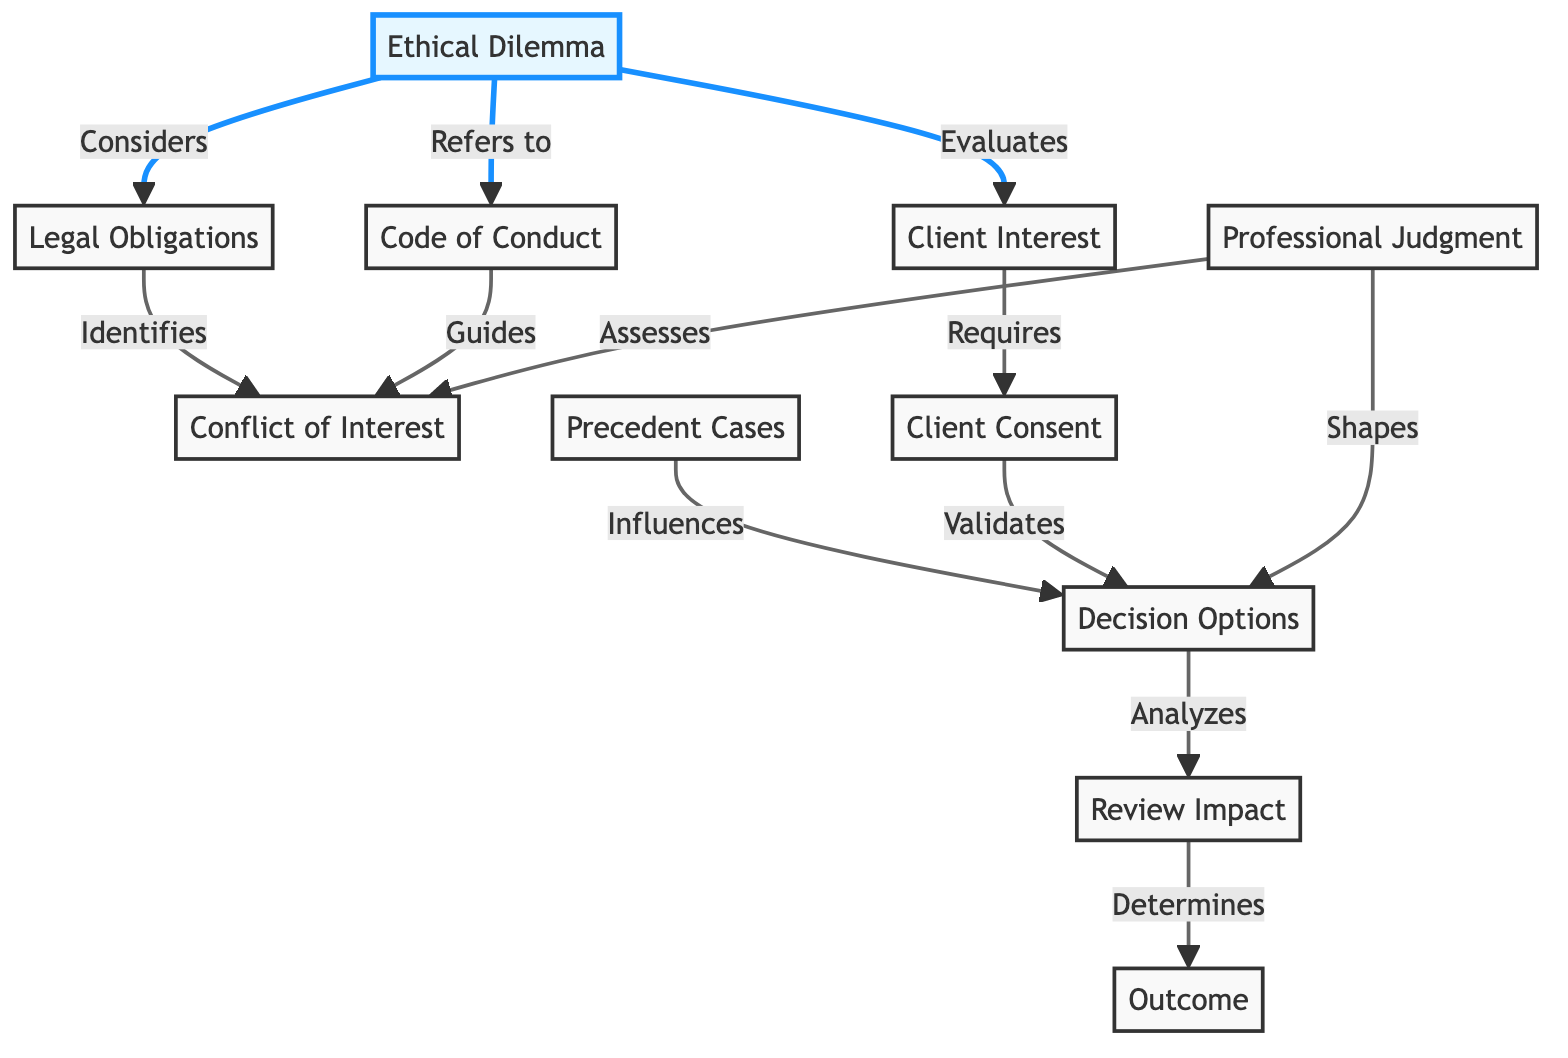What is the number of nodes in the diagram? The diagram lists 11 distinct nodes. Each node represents a different aspect of ethical decision-making in legal practice. By counting these, we find that there are 11 nodes in total.
Answer: 11 Which node is connected to "Ethical Dilemma" by the label "Considers"? The node that is connected to "Ethical Dilemma" by the label "Considers" is "Legal Obligations". This relationship indicates that an ethical dilemma takes into account the legal obligations related to the case.
Answer: Legal Obligations What does "Client Interest" require? "Client Interest" requires "Client Consent". This highlights the importance of obtaining consent from the client when considering their interests in the decision-making process.
Answer: Client Consent How many relationships does "Code of Conduct" have? "Code of Conduct" has two relationships: it refers to the "Ethical Dilemma" and guides the "Conflict of Interest". Counting these connections shows that it plays a significant role in guiding legal ethical considerations.
Answer: 2 What role does "Professional Judgment" play in the diagram? "Professional Judgment" assesses "Conflict of Interest" and shapes "Decision Options". This indicates that professional judgment is crucial in identifying conflicts and designing options for decision-making.
Answer: Assesses and Shapes What determines the "Outcome" in this diagram? The "Outcome" is determined by the "Review Impact". This suggests that the impact of the review process is a key factor in assessing the final decision or outcome in legal practice.
Answer: Review Impact Which node influences "Decision Options"? "Precedent Cases" influences "Decision Options". This indicates that prior case law plays a significant role in informing the choices available when making decisions in legal contexts.
Answer: Precedent Cases What does "Decision Options" analyze? "Decision Options" analyzes the "Review Impact". This relationship shows that the options available for decision-making will take the impact of the review into consideration.
Answer: Review Impact What action does "Client Consent" perform in relation to "Decision Options"? "Client Consent" validates "Decision Options". This means that obtaining consent from the client is essential to ensure that the choices made in the decision-making process are acceptable.
Answer: Validates 